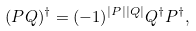Convert formula to latex. <formula><loc_0><loc_0><loc_500><loc_500>( P Q ) ^ { \dagger } = ( - 1 ) ^ { | P | | Q | } Q ^ { \dagger } P ^ { \dagger } ,</formula> 